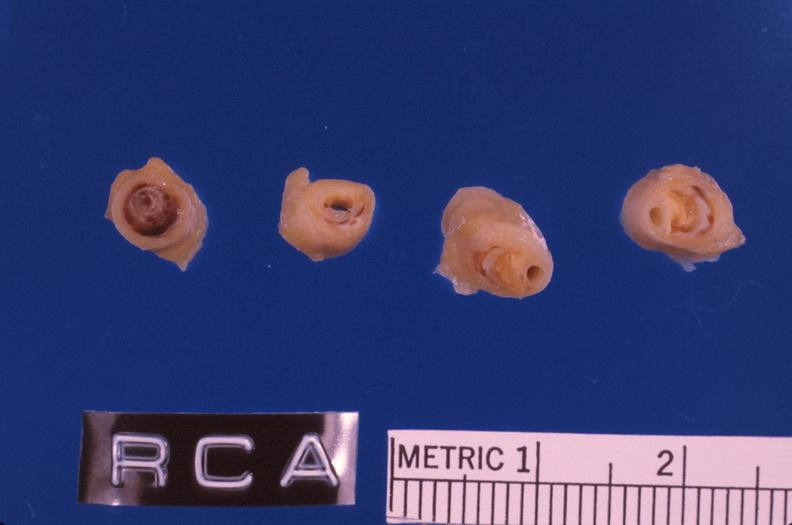s cardiovascular present?
Answer the question using a single word or phrase. Yes 